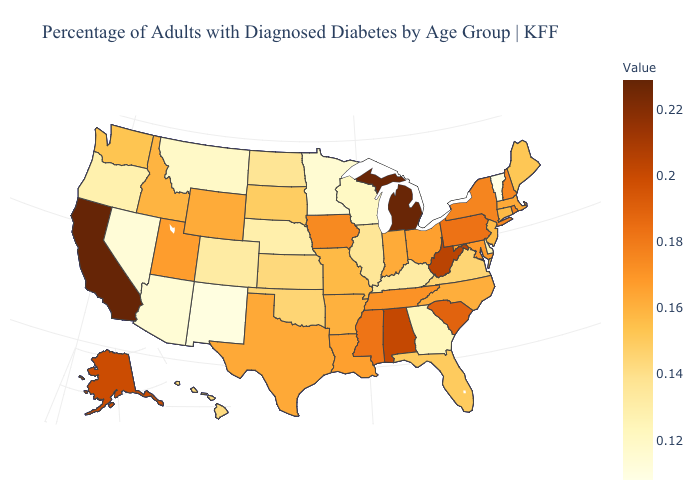Which states have the lowest value in the USA?
Give a very brief answer. Vermont. Which states have the lowest value in the MidWest?
Short answer required. Minnesota. Does New Mexico have the lowest value in the West?
Keep it brief. Yes. Is the legend a continuous bar?
Give a very brief answer. Yes. Does Arkansas have the highest value in the South?
Concise answer only. No. 